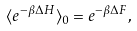Convert formula to latex. <formula><loc_0><loc_0><loc_500><loc_500>\langle e ^ { - \beta \Delta H } \rangle _ { 0 } = e ^ { - \beta \Delta F } ,</formula> 